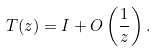Convert formula to latex. <formula><loc_0><loc_0><loc_500><loc_500>T ( z ) = I + O \left ( \frac { 1 } { z } \right ) .</formula> 